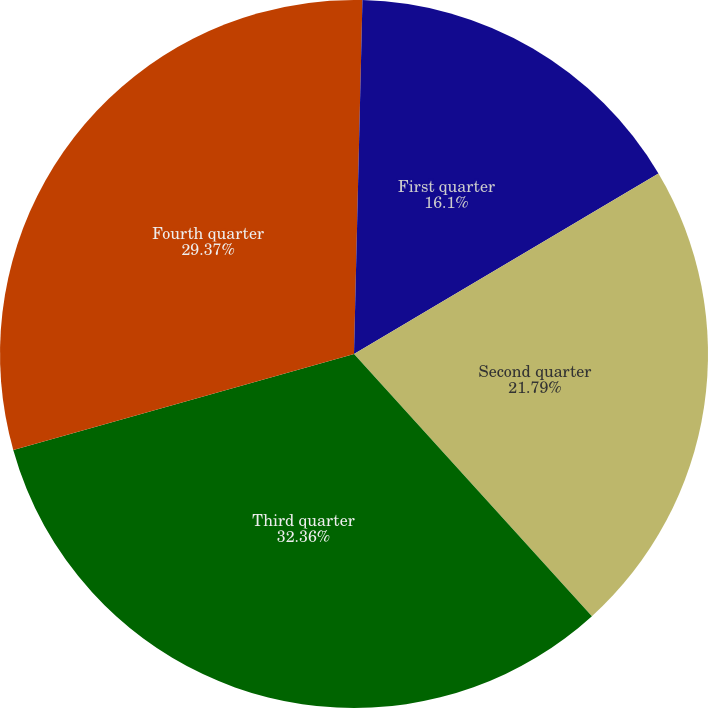Convert chart. <chart><loc_0><loc_0><loc_500><loc_500><pie_chart><fcel>Peak borrowings<fcel>First quarter<fcel>Second quarter<fcel>Third quarter<fcel>Fourth quarter<nl><fcel>0.38%<fcel>16.1%<fcel>21.79%<fcel>32.36%<fcel>29.37%<nl></chart> 